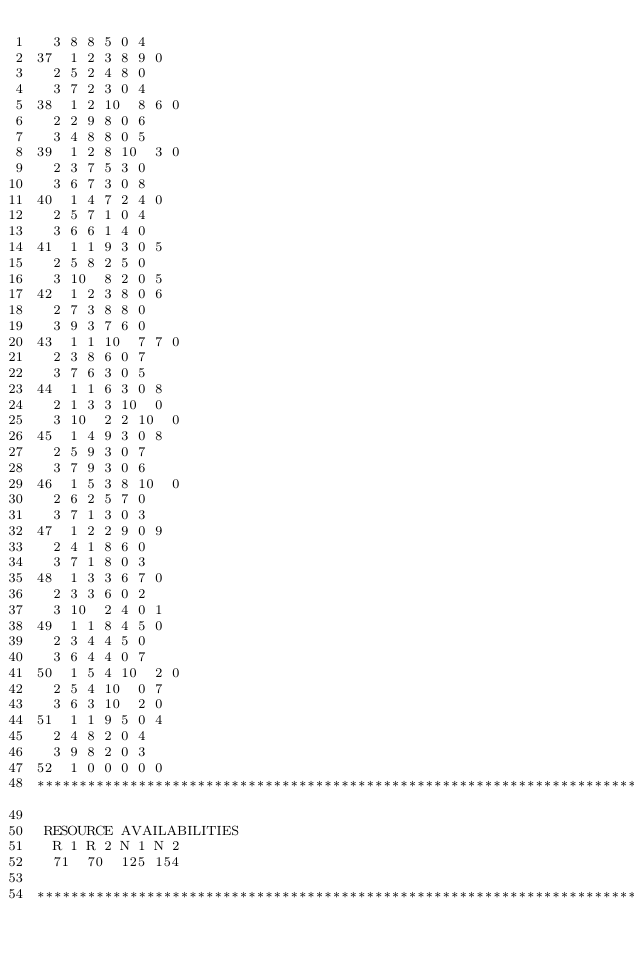<code> <loc_0><loc_0><loc_500><loc_500><_ObjectiveC_>	3	8	8	5	0	4	
37	1	2	3	8	9	0	
	2	5	2	4	8	0	
	3	7	2	3	0	4	
38	1	2	10	8	6	0	
	2	2	9	8	0	6	
	3	4	8	8	0	5	
39	1	2	8	10	3	0	
	2	3	7	5	3	0	
	3	6	7	3	0	8	
40	1	4	7	2	4	0	
	2	5	7	1	0	4	
	3	6	6	1	4	0	
41	1	1	9	3	0	5	
	2	5	8	2	5	0	
	3	10	8	2	0	5	
42	1	2	3	8	0	6	
	2	7	3	8	8	0	
	3	9	3	7	6	0	
43	1	1	10	7	7	0	
	2	3	8	6	0	7	
	3	7	6	3	0	5	
44	1	1	6	3	0	8	
	2	1	3	3	10	0	
	3	10	2	2	10	0	
45	1	4	9	3	0	8	
	2	5	9	3	0	7	
	3	7	9	3	0	6	
46	1	5	3	8	10	0	
	2	6	2	5	7	0	
	3	7	1	3	0	3	
47	1	2	2	9	0	9	
	2	4	1	8	6	0	
	3	7	1	8	0	3	
48	1	3	3	6	7	0	
	2	3	3	6	0	2	
	3	10	2	4	0	1	
49	1	1	8	4	5	0	
	2	3	4	4	5	0	
	3	6	4	4	0	7	
50	1	5	4	10	2	0	
	2	5	4	10	0	7	
	3	6	3	10	2	0	
51	1	1	9	5	0	4	
	2	4	8	2	0	4	
	3	9	8	2	0	3	
52	1	0	0	0	0	0	
************************************************************************

 RESOURCE AVAILABILITIES 
	R 1	R 2	N 1	N 2
	71	70	125	154

************************************************************************
</code> 